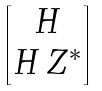Convert formula to latex. <formula><loc_0><loc_0><loc_500><loc_500>\begin{bmatrix} H \\ H \, Z ^ { * } \end{bmatrix}</formula> 